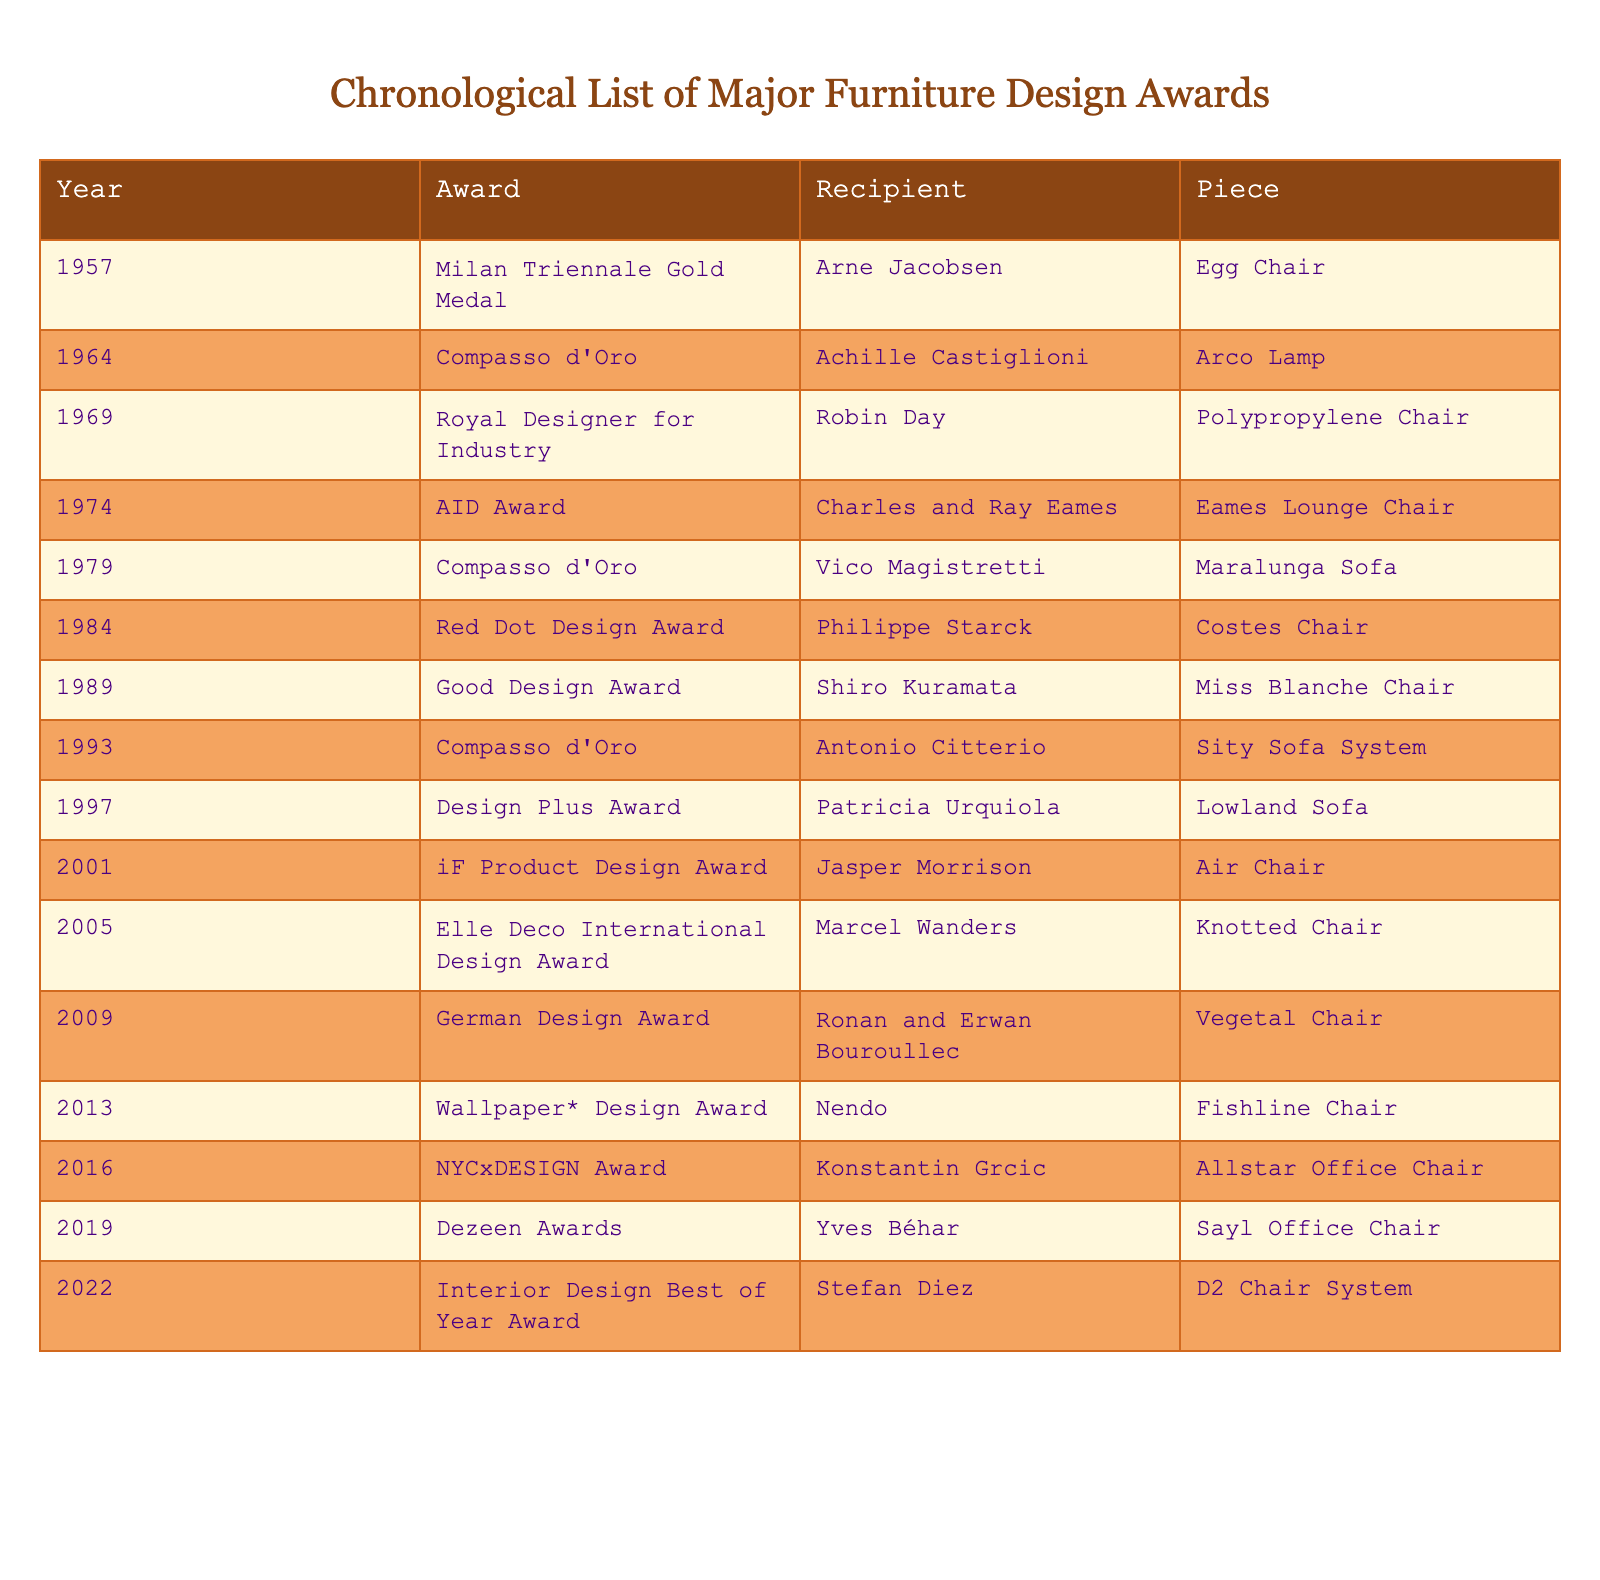What year did Arne Jacobsen win the Milan Triennale Gold Medal? The table shows that Arne Jacobsen received the Milan Triennale Gold Medal in 1957.
Answer: 1957 Which award did Philippe Starck receive for the Costes Chair? The table indicates that Philippe Starck received the Red Dot Design Award for the Costes Chair in 1984.
Answer: Red Dot Design Award How many awards were given out in the 2000s? The table lists 6 awards given from 2001 to 2009 (iF Product Design Award, Elle Deco International Design Award, German Design Award, etc.).
Answer: 6 Who was the recipient of the Compasso d'Oro in 1993? According to the table, the recipient of the Compasso d'Oro in 1993 was Antonio Citterio for the Sity Sofa System.
Answer: Antonio Citterio Which piece won the Good Design Award in 1989? The table states that the Miss Blanche Chair by Shiro Kuramata won the Good Design Award in 1989.
Answer: Miss Blanche Chair Is it true that the same recipient won awards in both the 1970s and the 2000s? Yes, Charles and Ray Eames won the AID Award for the Eames Lounge Chair in 1974, and Jasper Morrison received the iF Product Design Award for the Air Chair in 2001. Both are recipients from different decades.
Answer: Yes Which award had the most recent recipient listed in the table? The table shows that the most recent award was the Interior Design Best of Year Award given to Stefan Diez for the D2 Chair System in 2022.
Answer: Interior Design Best of Year Award How many years apart were the awards received by Vico Magistretti and Konstantin Grcic? Vico Magistretti received his award in 1979 and Konstantin Grcic in 2016. The difference is 2016 - 1979 = 37 years.
Answer: 37 years What is the total number of unique awards listed in the table? Upon examining the awards listed, there are 12 unique awards given to various recipients throughout the years.
Answer: 12 Who received the AID Award? The table indicates that the AID Award was given to Charles and Ray Eames for the Eames Lounge Chair in 1974.
Answer: Charles and Ray Eames 